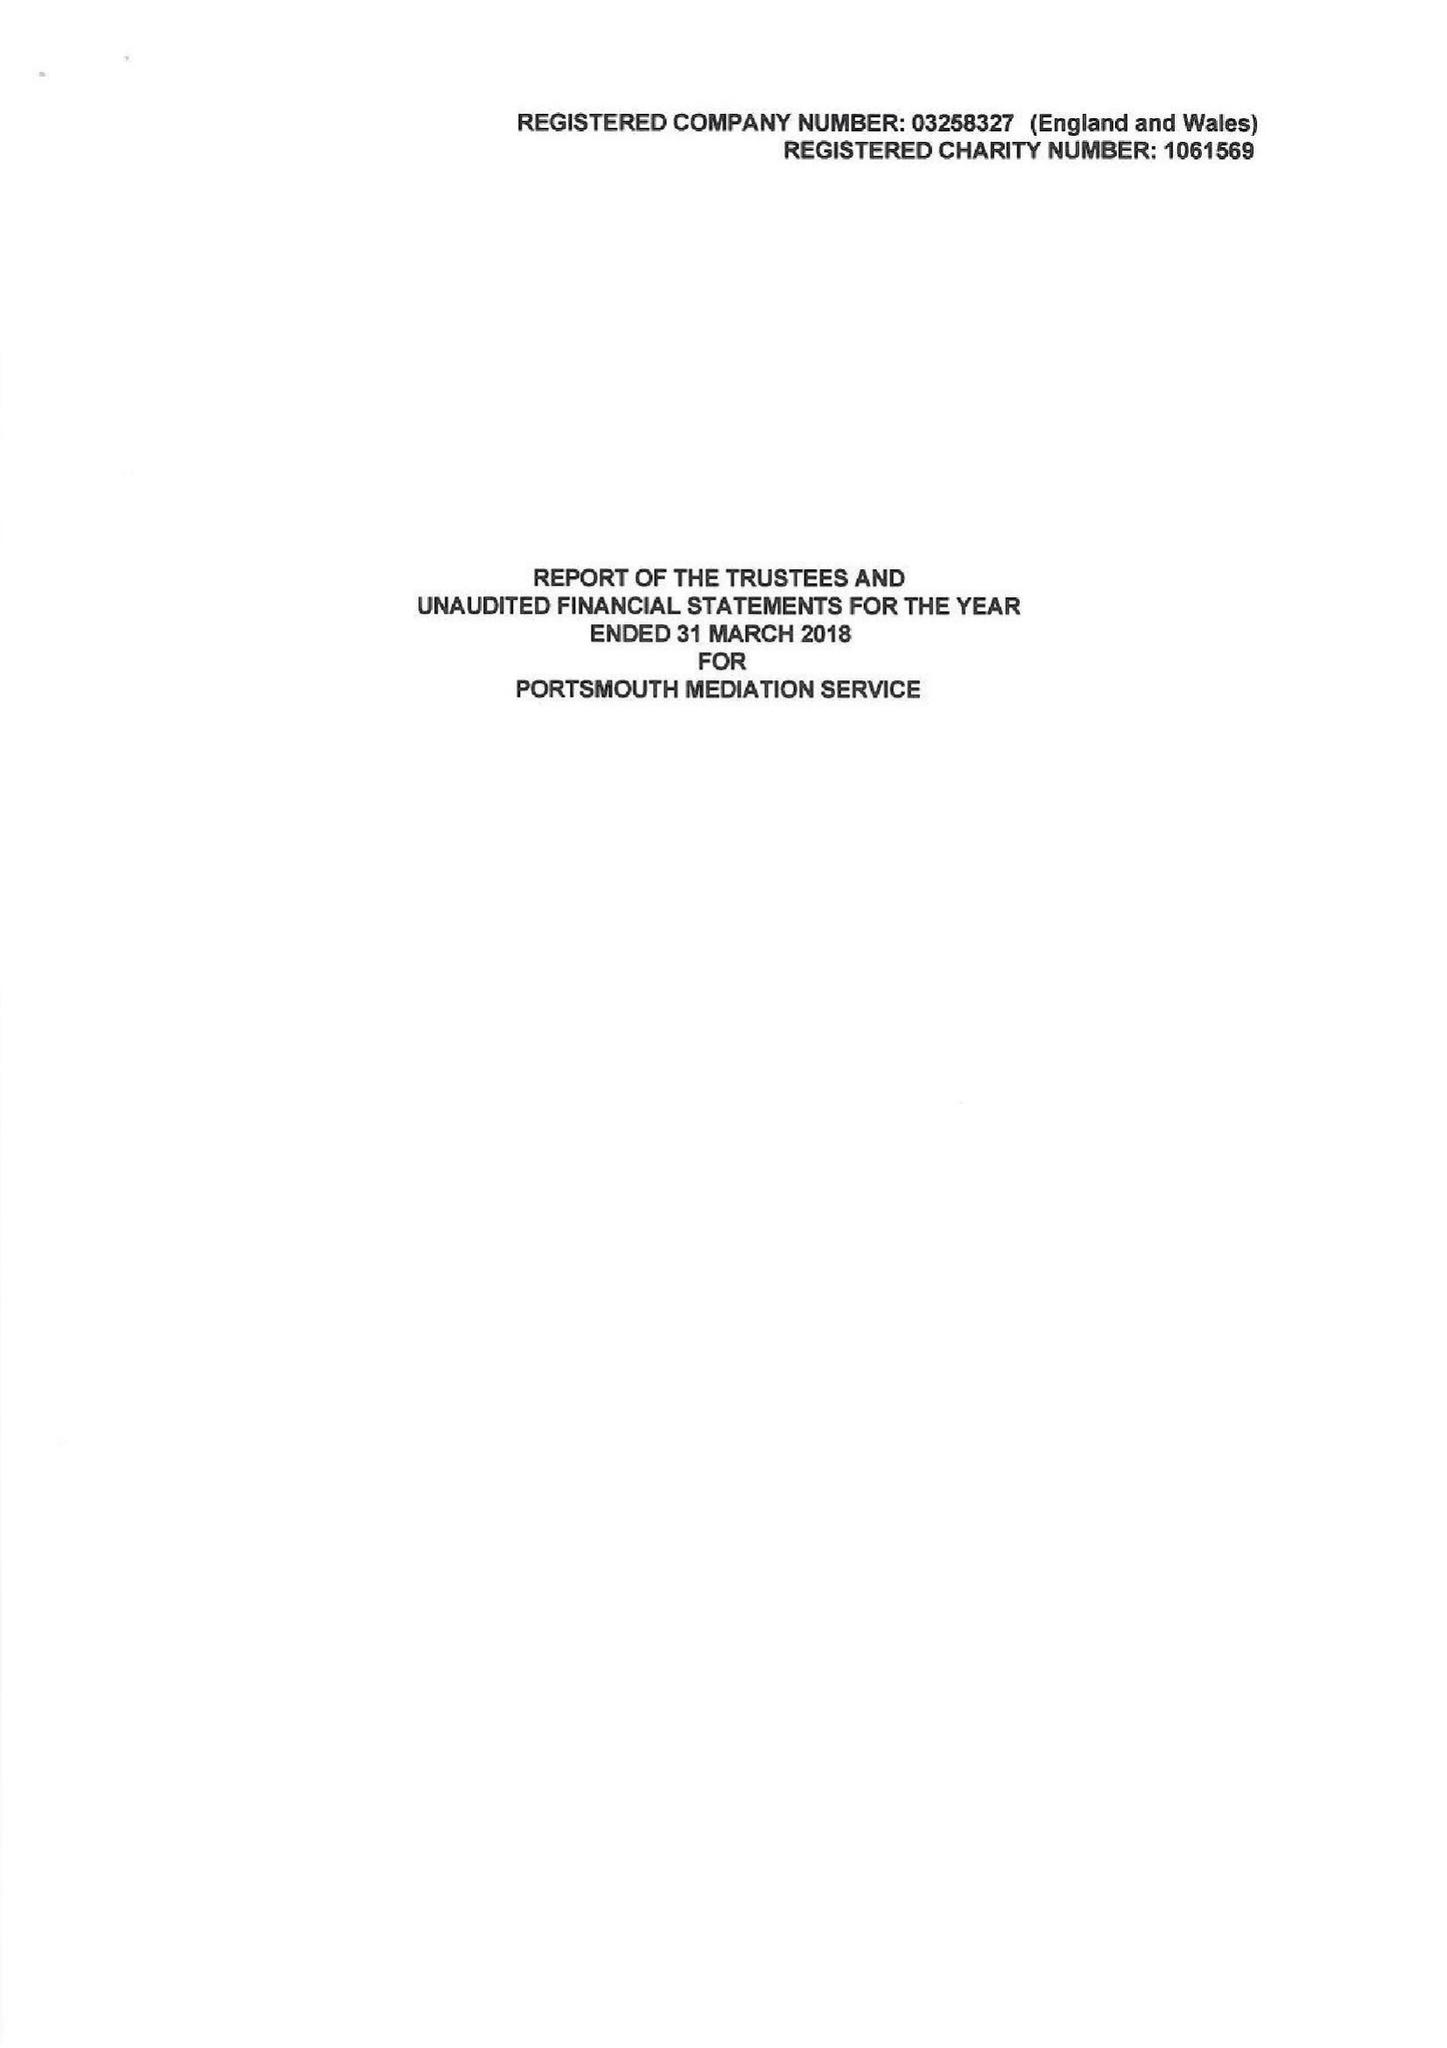What is the value for the report_date?
Answer the question using a single word or phrase. 2018-03-31 